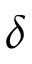<formula> <loc_0><loc_0><loc_500><loc_500>\delta</formula> 